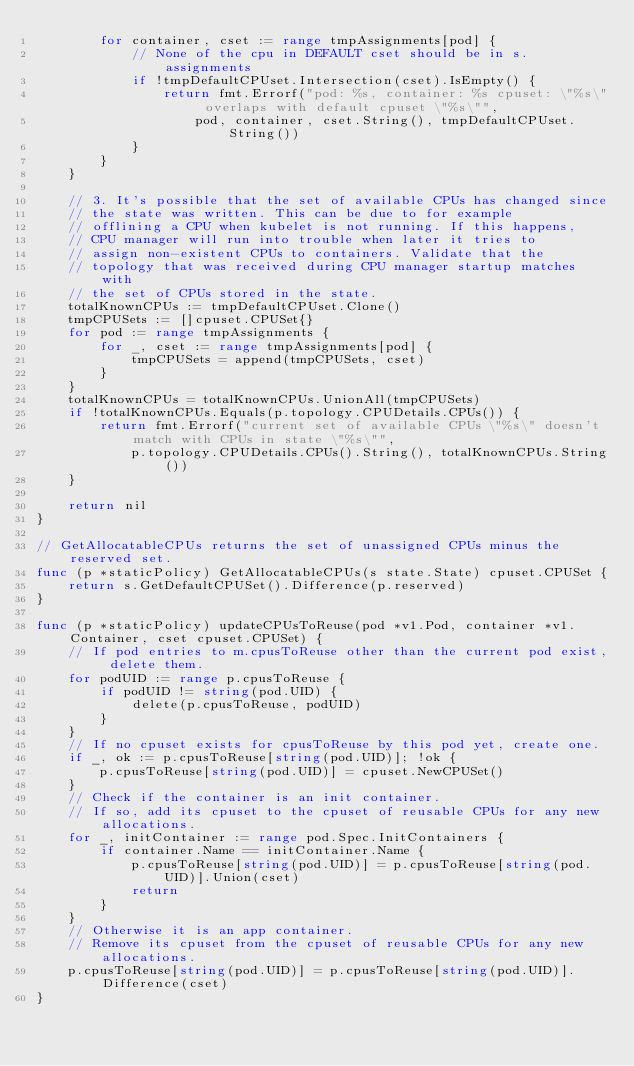Convert code to text. <code><loc_0><loc_0><loc_500><loc_500><_Go_>		for container, cset := range tmpAssignments[pod] {
			// None of the cpu in DEFAULT cset should be in s.assignments
			if !tmpDefaultCPUset.Intersection(cset).IsEmpty() {
				return fmt.Errorf("pod: %s, container: %s cpuset: \"%s\" overlaps with default cpuset \"%s\"",
					pod, container, cset.String(), tmpDefaultCPUset.String())
			}
		}
	}

	// 3. It's possible that the set of available CPUs has changed since
	// the state was written. This can be due to for example
	// offlining a CPU when kubelet is not running. If this happens,
	// CPU manager will run into trouble when later it tries to
	// assign non-existent CPUs to containers. Validate that the
	// topology that was received during CPU manager startup matches with
	// the set of CPUs stored in the state.
	totalKnownCPUs := tmpDefaultCPUset.Clone()
	tmpCPUSets := []cpuset.CPUSet{}
	for pod := range tmpAssignments {
		for _, cset := range tmpAssignments[pod] {
			tmpCPUSets = append(tmpCPUSets, cset)
		}
	}
	totalKnownCPUs = totalKnownCPUs.UnionAll(tmpCPUSets)
	if !totalKnownCPUs.Equals(p.topology.CPUDetails.CPUs()) {
		return fmt.Errorf("current set of available CPUs \"%s\" doesn't match with CPUs in state \"%s\"",
			p.topology.CPUDetails.CPUs().String(), totalKnownCPUs.String())
	}

	return nil
}

// GetAllocatableCPUs returns the set of unassigned CPUs minus the reserved set.
func (p *staticPolicy) GetAllocatableCPUs(s state.State) cpuset.CPUSet {
	return s.GetDefaultCPUSet().Difference(p.reserved)
}

func (p *staticPolicy) updateCPUsToReuse(pod *v1.Pod, container *v1.Container, cset cpuset.CPUSet) {
	// If pod entries to m.cpusToReuse other than the current pod exist, delete them.
	for podUID := range p.cpusToReuse {
		if podUID != string(pod.UID) {
			delete(p.cpusToReuse, podUID)
		}
	}
	// If no cpuset exists for cpusToReuse by this pod yet, create one.
	if _, ok := p.cpusToReuse[string(pod.UID)]; !ok {
		p.cpusToReuse[string(pod.UID)] = cpuset.NewCPUSet()
	}
	// Check if the container is an init container.
	// If so, add its cpuset to the cpuset of reusable CPUs for any new allocations.
	for _, initContainer := range pod.Spec.InitContainers {
		if container.Name == initContainer.Name {
			p.cpusToReuse[string(pod.UID)] = p.cpusToReuse[string(pod.UID)].Union(cset)
			return
		}
	}
	// Otherwise it is an app container.
	// Remove its cpuset from the cpuset of reusable CPUs for any new allocations.
	p.cpusToReuse[string(pod.UID)] = p.cpusToReuse[string(pod.UID)].Difference(cset)
}
</code> 